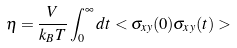Convert formula to latex. <formula><loc_0><loc_0><loc_500><loc_500>\eta = \frac { V } { k _ { B } T } \int _ { 0 } ^ { \infty } d t < \sigma _ { x y } ( 0 ) \sigma _ { x y } ( t ) ></formula> 